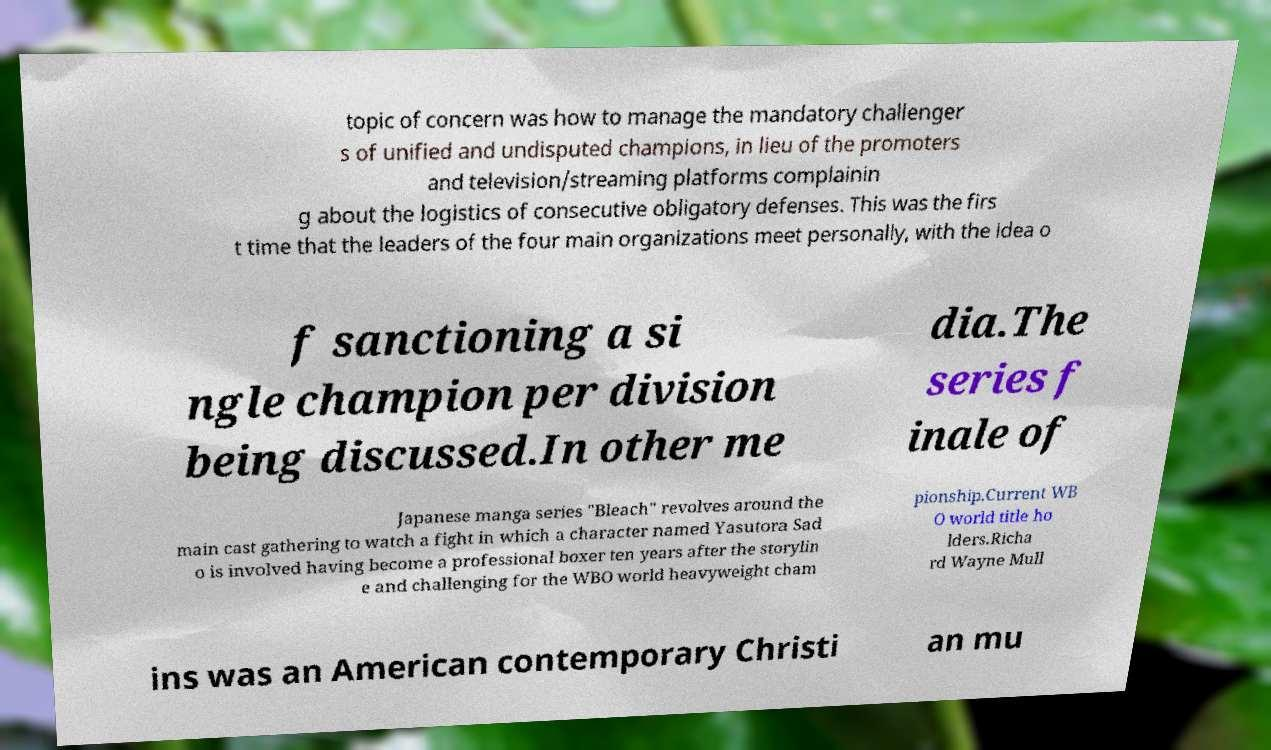Please read and relay the text visible in this image. What does it say? topic of concern was how to manage the mandatory challenger s of unified and undisputed champions, in lieu of the promoters and television/streaming platforms complainin g about the logistics of consecutive obligatory defenses. This was the firs t time that the leaders of the four main organizations meet personally, with the idea o f sanctioning a si ngle champion per division being discussed.In other me dia.The series f inale of Japanese manga series "Bleach" revolves around the main cast gathering to watch a fight in which a character named Yasutora Sad o is involved having become a professional boxer ten years after the storylin e and challenging for the WBO world heavyweight cham pionship.Current WB O world title ho lders.Richa rd Wayne Mull ins was an American contemporary Christi an mu 